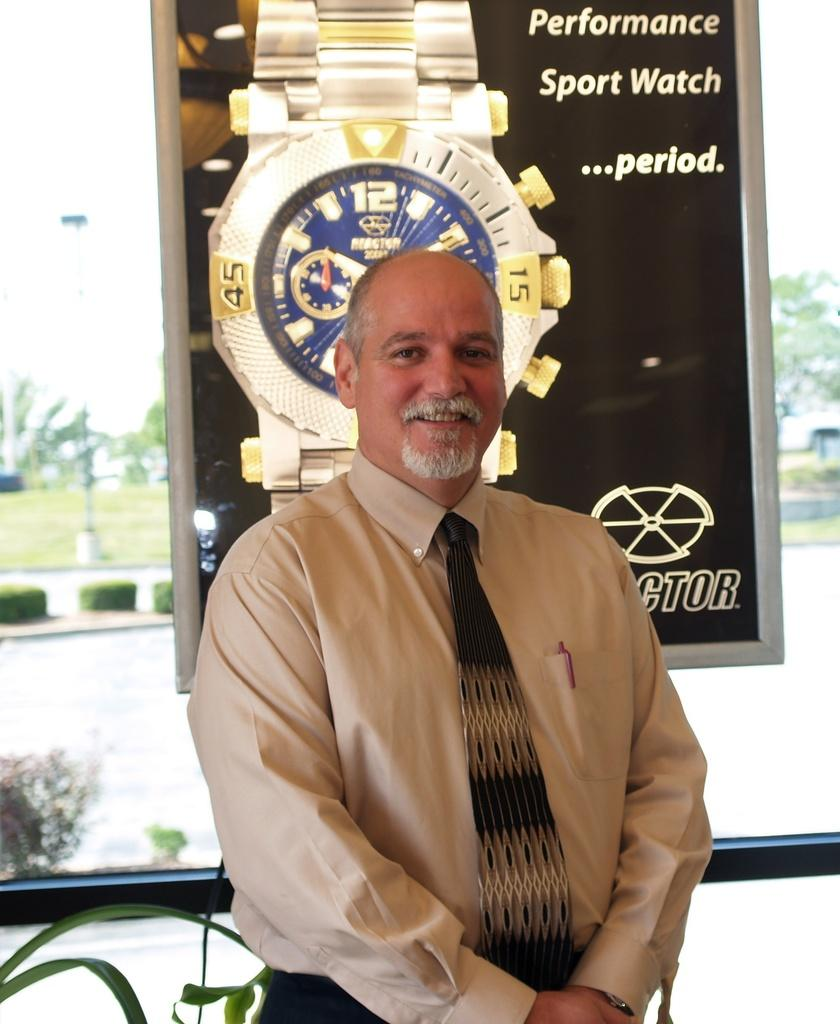<image>
Provide a brief description of the given image. A man wearing a tie poses in front of a sport watch ad poster. 